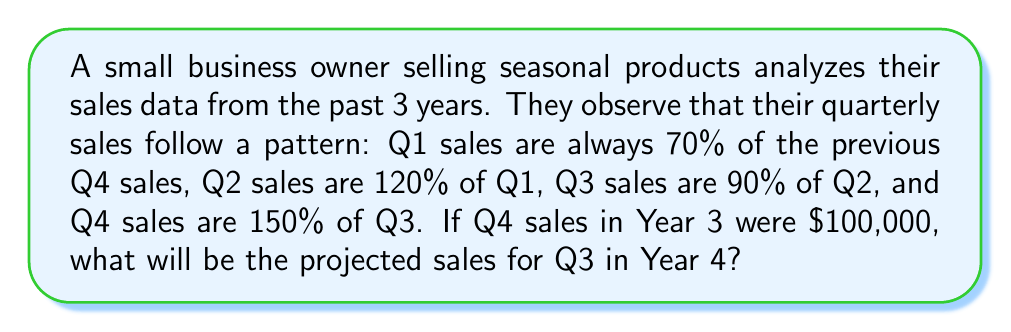Show me your answer to this math problem. Let's approach this step-by-step:

1) We start with Q4 sales in Year 3: $100,000

2) To find Q1 sales in Year 4:
   Q1 = 70% of previous Q4
   $Q1 = 0.70 \times \$100,000 = \$70,000$

3) To find Q2 sales in Year 4:
   Q2 = 120% of Q1
   $Q2 = 1.20 \times \$70,000 = \$84,000$

4) To find Q3 sales in Year 4:
   Q3 = 90% of Q2
   $Q3 = 0.90 \times \$84,000 = \$75,600$

We can also express this as a single equation:

$$Q3_{Year4} = 0.90 \times (1.20 \times (0.70 \times Q4_{Year3}))$$

Substituting the values:

$$Q3_{Year4} = 0.90 \times (1.20 \times (0.70 \times \$100,000)) = \$75,600$$
Answer: $75,600 